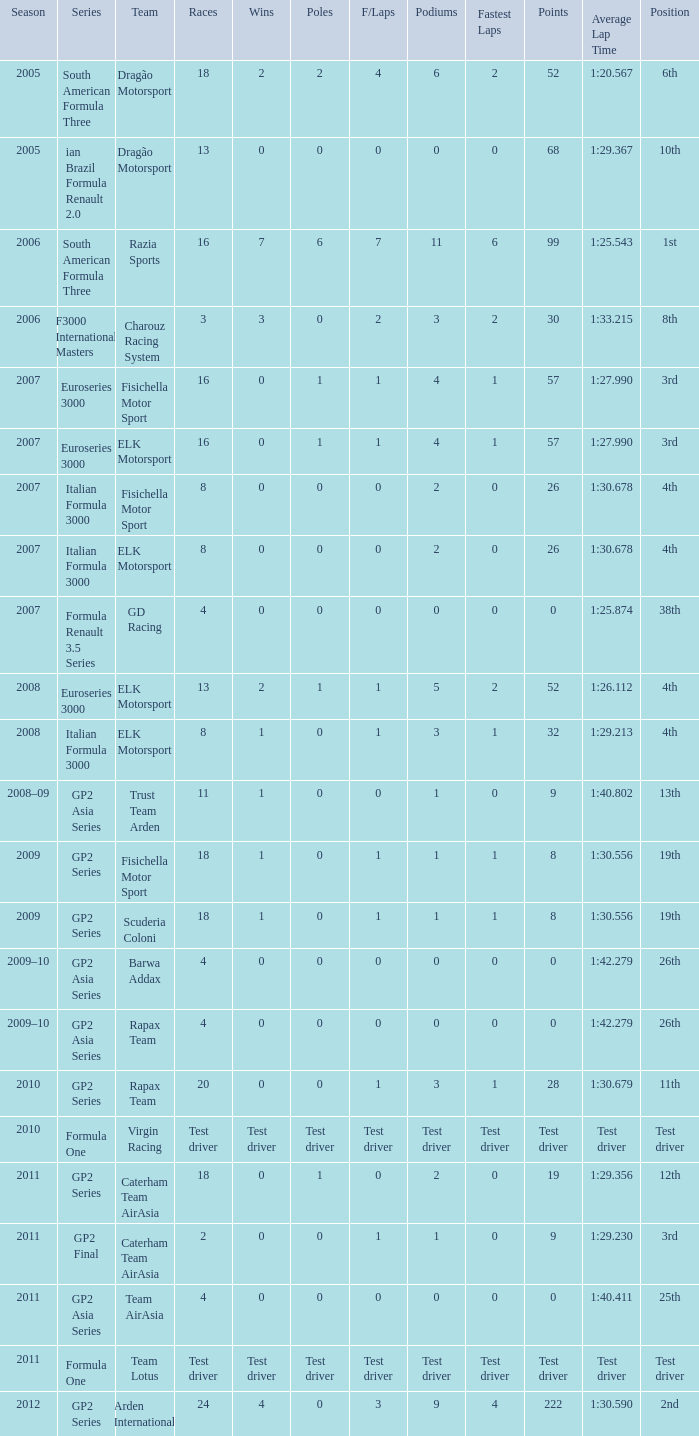What was the F/Laps when the Wins were 0 and the Position was 4th? 0, 0. 